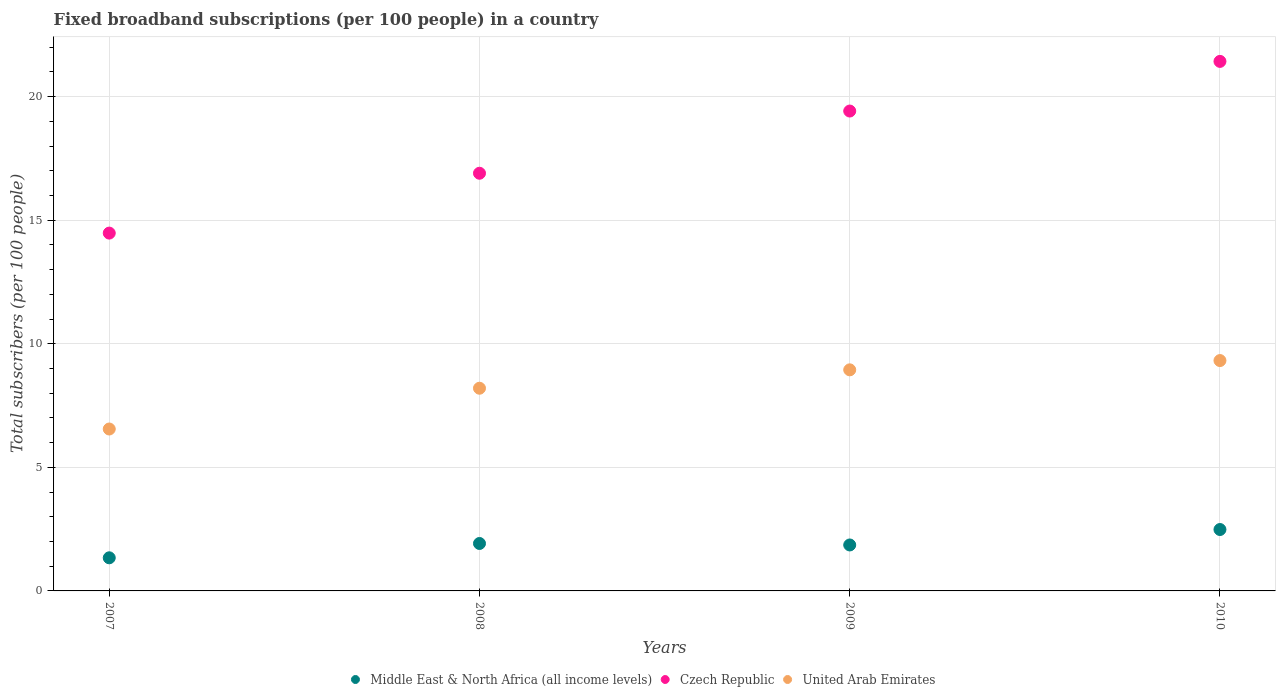How many different coloured dotlines are there?
Your answer should be compact. 3. Is the number of dotlines equal to the number of legend labels?
Your response must be concise. Yes. What is the number of broadband subscriptions in Czech Republic in 2009?
Your response must be concise. 19.42. Across all years, what is the maximum number of broadband subscriptions in United Arab Emirates?
Give a very brief answer. 9.32. Across all years, what is the minimum number of broadband subscriptions in United Arab Emirates?
Your answer should be compact. 6.55. In which year was the number of broadband subscriptions in United Arab Emirates maximum?
Offer a very short reply. 2010. In which year was the number of broadband subscriptions in Czech Republic minimum?
Ensure brevity in your answer.  2007. What is the total number of broadband subscriptions in Czech Republic in the graph?
Provide a succinct answer. 72.22. What is the difference between the number of broadband subscriptions in United Arab Emirates in 2008 and that in 2009?
Offer a very short reply. -0.74. What is the difference between the number of broadband subscriptions in United Arab Emirates in 2008 and the number of broadband subscriptions in Middle East & North Africa (all income levels) in 2007?
Provide a succinct answer. 6.86. What is the average number of broadband subscriptions in United Arab Emirates per year?
Make the answer very short. 8.25. In the year 2009, what is the difference between the number of broadband subscriptions in Czech Republic and number of broadband subscriptions in United Arab Emirates?
Ensure brevity in your answer.  10.47. What is the ratio of the number of broadband subscriptions in Middle East & North Africa (all income levels) in 2007 to that in 2008?
Offer a very short reply. 0.7. What is the difference between the highest and the second highest number of broadband subscriptions in United Arab Emirates?
Your answer should be very brief. 0.38. What is the difference between the highest and the lowest number of broadband subscriptions in Middle East & North Africa (all income levels)?
Your response must be concise. 1.14. Is it the case that in every year, the sum of the number of broadband subscriptions in Czech Republic and number of broadband subscriptions in Middle East & North Africa (all income levels)  is greater than the number of broadband subscriptions in United Arab Emirates?
Offer a very short reply. Yes. Is the number of broadband subscriptions in Czech Republic strictly less than the number of broadband subscriptions in United Arab Emirates over the years?
Keep it short and to the point. No. Are the values on the major ticks of Y-axis written in scientific E-notation?
Ensure brevity in your answer.  No. Does the graph contain any zero values?
Provide a succinct answer. No. Where does the legend appear in the graph?
Give a very brief answer. Bottom center. How many legend labels are there?
Offer a terse response. 3. How are the legend labels stacked?
Make the answer very short. Horizontal. What is the title of the graph?
Provide a succinct answer. Fixed broadband subscriptions (per 100 people) in a country. Does "High income: OECD" appear as one of the legend labels in the graph?
Your answer should be compact. No. What is the label or title of the Y-axis?
Provide a succinct answer. Total subscribers (per 100 people). What is the Total subscribers (per 100 people) in Middle East & North Africa (all income levels) in 2007?
Make the answer very short. 1.34. What is the Total subscribers (per 100 people) in Czech Republic in 2007?
Offer a terse response. 14.48. What is the Total subscribers (per 100 people) in United Arab Emirates in 2007?
Ensure brevity in your answer.  6.55. What is the Total subscribers (per 100 people) in Middle East & North Africa (all income levels) in 2008?
Offer a terse response. 1.92. What is the Total subscribers (per 100 people) of Czech Republic in 2008?
Provide a short and direct response. 16.9. What is the Total subscribers (per 100 people) in United Arab Emirates in 2008?
Offer a very short reply. 8.2. What is the Total subscribers (per 100 people) in Middle East & North Africa (all income levels) in 2009?
Provide a succinct answer. 1.86. What is the Total subscribers (per 100 people) of Czech Republic in 2009?
Provide a succinct answer. 19.42. What is the Total subscribers (per 100 people) in United Arab Emirates in 2009?
Ensure brevity in your answer.  8.95. What is the Total subscribers (per 100 people) in Middle East & North Africa (all income levels) in 2010?
Your answer should be compact. 2.48. What is the Total subscribers (per 100 people) of Czech Republic in 2010?
Give a very brief answer. 21.43. What is the Total subscribers (per 100 people) of United Arab Emirates in 2010?
Provide a short and direct response. 9.32. Across all years, what is the maximum Total subscribers (per 100 people) in Middle East & North Africa (all income levels)?
Offer a terse response. 2.48. Across all years, what is the maximum Total subscribers (per 100 people) in Czech Republic?
Your response must be concise. 21.43. Across all years, what is the maximum Total subscribers (per 100 people) in United Arab Emirates?
Provide a succinct answer. 9.32. Across all years, what is the minimum Total subscribers (per 100 people) in Middle East & North Africa (all income levels)?
Give a very brief answer. 1.34. Across all years, what is the minimum Total subscribers (per 100 people) of Czech Republic?
Offer a very short reply. 14.48. Across all years, what is the minimum Total subscribers (per 100 people) of United Arab Emirates?
Offer a very short reply. 6.55. What is the total Total subscribers (per 100 people) in Middle East & North Africa (all income levels) in the graph?
Your answer should be compact. 7.6. What is the total Total subscribers (per 100 people) in Czech Republic in the graph?
Make the answer very short. 72.22. What is the total Total subscribers (per 100 people) of United Arab Emirates in the graph?
Give a very brief answer. 33.02. What is the difference between the Total subscribers (per 100 people) in Middle East & North Africa (all income levels) in 2007 and that in 2008?
Offer a terse response. -0.58. What is the difference between the Total subscribers (per 100 people) of Czech Republic in 2007 and that in 2008?
Offer a terse response. -2.42. What is the difference between the Total subscribers (per 100 people) of United Arab Emirates in 2007 and that in 2008?
Your answer should be compact. -1.65. What is the difference between the Total subscribers (per 100 people) in Middle East & North Africa (all income levels) in 2007 and that in 2009?
Provide a short and direct response. -0.52. What is the difference between the Total subscribers (per 100 people) in Czech Republic in 2007 and that in 2009?
Provide a short and direct response. -4.94. What is the difference between the Total subscribers (per 100 people) in United Arab Emirates in 2007 and that in 2009?
Give a very brief answer. -2.39. What is the difference between the Total subscribers (per 100 people) of Middle East & North Africa (all income levels) in 2007 and that in 2010?
Offer a terse response. -1.14. What is the difference between the Total subscribers (per 100 people) in Czech Republic in 2007 and that in 2010?
Provide a succinct answer. -6.95. What is the difference between the Total subscribers (per 100 people) of United Arab Emirates in 2007 and that in 2010?
Your answer should be compact. -2.77. What is the difference between the Total subscribers (per 100 people) in Middle East & North Africa (all income levels) in 2008 and that in 2009?
Provide a succinct answer. 0.06. What is the difference between the Total subscribers (per 100 people) of Czech Republic in 2008 and that in 2009?
Ensure brevity in your answer.  -2.52. What is the difference between the Total subscribers (per 100 people) in United Arab Emirates in 2008 and that in 2009?
Provide a short and direct response. -0.74. What is the difference between the Total subscribers (per 100 people) of Middle East & North Africa (all income levels) in 2008 and that in 2010?
Keep it short and to the point. -0.56. What is the difference between the Total subscribers (per 100 people) of Czech Republic in 2008 and that in 2010?
Provide a succinct answer. -4.53. What is the difference between the Total subscribers (per 100 people) in United Arab Emirates in 2008 and that in 2010?
Keep it short and to the point. -1.12. What is the difference between the Total subscribers (per 100 people) in Middle East & North Africa (all income levels) in 2009 and that in 2010?
Your answer should be compact. -0.63. What is the difference between the Total subscribers (per 100 people) of Czech Republic in 2009 and that in 2010?
Offer a very short reply. -2.01. What is the difference between the Total subscribers (per 100 people) in United Arab Emirates in 2009 and that in 2010?
Your response must be concise. -0.38. What is the difference between the Total subscribers (per 100 people) of Middle East & North Africa (all income levels) in 2007 and the Total subscribers (per 100 people) of Czech Republic in 2008?
Ensure brevity in your answer.  -15.56. What is the difference between the Total subscribers (per 100 people) of Middle East & North Africa (all income levels) in 2007 and the Total subscribers (per 100 people) of United Arab Emirates in 2008?
Offer a very short reply. -6.86. What is the difference between the Total subscribers (per 100 people) of Czech Republic in 2007 and the Total subscribers (per 100 people) of United Arab Emirates in 2008?
Provide a succinct answer. 6.28. What is the difference between the Total subscribers (per 100 people) in Middle East & North Africa (all income levels) in 2007 and the Total subscribers (per 100 people) in Czech Republic in 2009?
Provide a succinct answer. -18.08. What is the difference between the Total subscribers (per 100 people) in Middle East & North Africa (all income levels) in 2007 and the Total subscribers (per 100 people) in United Arab Emirates in 2009?
Ensure brevity in your answer.  -7.61. What is the difference between the Total subscribers (per 100 people) in Czech Republic in 2007 and the Total subscribers (per 100 people) in United Arab Emirates in 2009?
Provide a succinct answer. 5.53. What is the difference between the Total subscribers (per 100 people) in Middle East & North Africa (all income levels) in 2007 and the Total subscribers (per 100 people) in Czech Republic in 2010?
Offer a terse response. -20.09. What is the difference between the Total subscribers (per 100 people) of Middle East & North Africa (all income levels) in 2007 and the Total subscribers (per 100 people) of United Arab Emirates in 2010?
Provide a short and direct response. -7.98. What is the difference between the Total subscribers (per 100 people) of Czech Republic in 2007 and the Total subscribers (per 100 people) of United Arab Emirates in 2010?
Keep it short and to the point. 5.16. What is the difference between the Total subscribers (per 100 people) of Middle East & North Africa (all income levels) in 2008 and the Total subscribers (per 100 people) of Czech Republic in 2009?
Your response must be concise. -17.5. What is the difference between the Total subscribers (per 100 people) of Middle East & North Africa (all income levels) in 2008 and the Total subscribers (per 100 people) of United Arab Emirates in 2009?
Your answer should be very brief. -7.03. What is the difference between the Total subscribers (per 100 people) of Czech Republic in 2008 and the Total subscribers (per 100 people) of United Arab Emirates in 2009?
Your answer should be compact. 7.95. What is the difference between the Total subscribers (per 100 people) in Middle East & North Africa (all income levels) in 2008 and the Total subscribers (per 100 people) in Czech Republic in 2010?
Offer a terse response. -19.51. What is the difference between the Total subscribers (per 100 people) of Middle East & North Africa (all income levels) in 2008 and the Total subscribers (per 100 people) of United Arab Emirates in 2010?
Your response must be concise. -7.4. What is the difference between the Total subscribers (per 100 people) of Czech Republic in 2008 and the Total subscribers (per 100 people) of United Arab Emirates in 2010?
Make the answer very short. 7.58. What is the difference between the Total subscribers (per 100 people) of Middle East & North Africa (all income levels) in 2009 and the Total subscribers (per 100 people) of Czech Republic in 2010?
Ensure brevity in your answer.  -19.57. What is the difference between the Total subscribers (per 100 people) in Middle East & North Africa (all income levels) in 2009 and the Total subscribers (per 100 people) in United Arab Emirates in 2010?
Provide a succinct answer. -7.46. What is the difference between the Total subscribers (per 100 people) in Czech Republic in 2009 and the Total subscribers (per 100 people) in United Arab Emirates in 2010?
Make the answer very short. 10.1. What is the average Total subscribers (per 100 people) in Middle East & North Africa (all income levels) per year?
Offer a very short reply. 1.9. What is the average Total subscribers (per 100 people) of Czech Republic per year?
Offer a terse response. 18.05. What is the average Total subscribers (per 100 people) in United Arab Emirates per year?
Offer a terse response. 8.25. In the year 2007, what is the difference between the Total subscribers (per 100 people) of Middle East & North Africa (all income levels) and Total subscribers (per 100 people) of Czech Republic?
Ensure brevity in your answer.  -13.14. In the year 2007, what is the difference between the Total subscribers (per 100 people) of Middle East & North Africa (all income levels) and Total subscribers (per 100 people) of United Arab Emirates?
Provide a short and direct response. -5.21. In the year 2007, what is the difference between the Total subscribers (per 100 people) of Czech Republic and Total subscribers (per 100 people) of United Arab Emirates?
Make the answer very short. 7.93. In the year 2008, what is the difference between the Total subscribers (per 100 people) in Middle East & North Africa (all income levels) and Total subscribers (per 100 people) in Czech Republic?
Ensure brevity in your answer.  -14.98. In the year 2008, what is the difference between the Total subscribers (per 100 people) in Middle East & North Africa (all income levels) and Total subscribers (per 100 people) in United Arab Emirates?
Provide a short and direct response. -6.28. In the year 2008, what is the difference between the Total subscribers (per 100 people) in Czech Republic and Total subscribers (per 100 people) in United Arab Emirates?
Provide a succinct answer. 8.7. In the year 2009, what is the difference between the Total subscribers (per 100 people) in Middle East & North Africa (all income levels) and Total subscribers (per 100 people) in Czech Republic?
Offer a terse response. -17.56. In the year 2009, what is the difference between the Total subscribers (per 100 people) in Middle East & North Africa (all income levels) and Total subscribers (per 100 people) in United Arab Emirates?
Make the answer very short. -7.09. In the year 2009, what is the difference between the Total subscribers (per 100 people) of Czech Republic and Total subscribers (per 100 people) of United Arab Emirates?
Make the answer very short. 10.47. In the year 2010, what is the difference between the Total subscribers (per 100 people) of Middle East & North Africa (all income levels) and Total subscribers (per 100 people) of Czech Republic?
Keep it short and to the point. -18.94. In the year 2010, what is the difference between the Total subscribers (per 100 people) in Middle East & North Africa (all income levels) and Total subscribers (per 100 people) in United Arab Emirates?
Keep it short and to the point. -6.84. In the year 2010, what is the difference between the Total subscribers (per 100 people) of Czech Republic and Total subscribers (per 100 people) of United Arab Emirates?
Keep it short and to the point. 12.1. What is the ratio of the Total subscribers (per 100 people) of Middle East & North Africa (all income levels) in 2007 to that in 2008?
Give a very brief answer. 0.7. What is the ratio of the Total subscribers (per 100 people) of Czech Republic in 2007 to that in 2008?
Your response must be concise. 0.86. What is the ratio of the Total subscribers (per 100 people) in United Arab Emirates in 2007 to that in 2008?
Offer a very short reply. 0.8. What is the ratio of the Total subscribers (per 100 people) of Middle East & North Africa (all income levels) in 2007 to that in 2009?
Offer a terse response. 0.72. What is the ratio of the Total subscribers (per 100 people) in Czech Republic in 2007 to that in 2009?
Your response must be concise. 0.75. What is the ratio of the Total subscribers (per 100 people) of United Arab Emirates in 2007 to that in 2009?
Offer a terse response. 0.73. What is the ratio of the Total subscribers (per 100 people) of Middle East & North Africa (all income levels) in 2007 to that in 2010?
Offer a very short reply. 0.54. What is the ratio of the Total subscribers (per 100 people) of Czech Republic in 2007 to that in 2010?
Offer a terse response. 0.68. What is the ratio of the Total subscribers (per 100 people) in United Arab Emirates in 2007 to that in 2010?
Your answer should be very brief. 0.7. What is the ratio of the Total subscribers (per 100 people) of Middle East & North Africa (all income levels) in 2008 to that in 2009?
Keep it short and to the point. 1.03. What is the ratio of the Total subscribers (per 100 people) of Czech Republic in 2008 to that in 2009?
Your answer should be compact. 0.87. What is the ratio of the Total subscribers (per 100 people) in United Arab Emirates in 2008 to that in 2009?
Give a very brief answer. 0.92. What is the ratio of the Total subscribers (per 100 people) in Middle East & North Africa (all income levels) in 2008 to that in 2010?
Ensure brevity in your answer.  0.77. What is the ratio of the Total subscribers (per 100 people) of Czech Republic in 2008 to that in 2010?
Offer a terse response. 0.79. What is the ratio of the Total subscribers (per 100 people) of United Arab Emirates in 2008 to that in 2010?
Your answer should be very brief. 0.88. What is the ratio of the Total subscribers (per 100 people) in Middle East & North Africa (all income levels) in 2009 to that in 2010?
Your response must be concise. 0.75. What is the ratio of the Total subscribers (per 100 people) in Czech Republic in 2009 to that in 2010?
Your answer should be compact. 0.91. What is the ratio of the Total subscribers (per 100 people) of United Arab Emirates in 2009 to that in 2010?
Make the answer very short. 0.96. What is the difference between the highest and the second highest Total subscribers (per 100 people) of Middle East & North Africa (all income levels)?
Provide a succinct answer. 0.56. What is the difference between the highest and the second highest Total subscribers (per 100 people) of Czech Republic?
Your response must be concise. 2.01. What is the difference between the highest and the second highest Total subscribers (per 100 people) of United Arab Emirates?
Offer a very short reply. 0.38. What is the difference between the highest and the lowest Total subscribers (per 100 people) of Middle East & North Africa (all income levels)?
Offer a very short reply. 1.14. What is the difference between the highest and the lowest Total subscribers (per 100 people) in Czech Republic?
Give a very brief answer. 6.95. What is the difference between the highest and the lowest Total subscribers (per 100 people) in United Arab Emirates?
Your response must be concise. 2.77. 